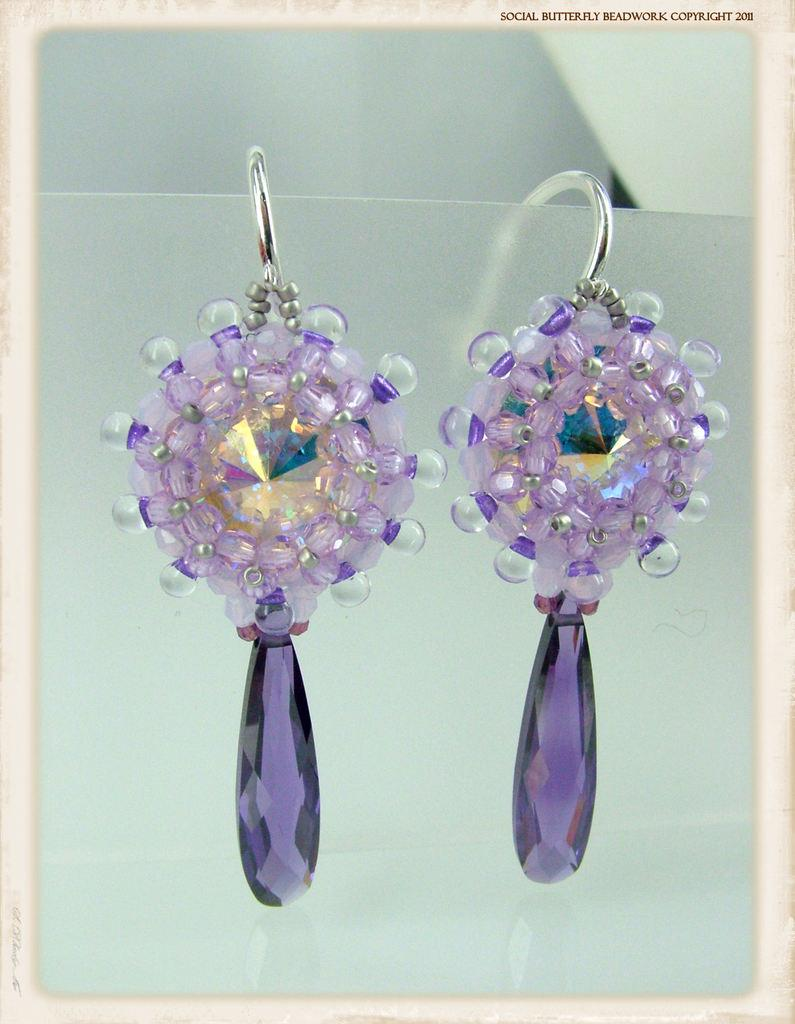What type of jewelry is featured in the image? There are two earrings in the image. How are the earrings displayed in the image? The earrings are placed on a card. Is there any text visible in the image? Yes, there is text on the right side top of the image. What is the overall appearance of the image? The image appears to be a frame containing the earrings. Which actor is holding the stem in the image? There is no actor or stem present in the image; it features earrings placed on a card. 